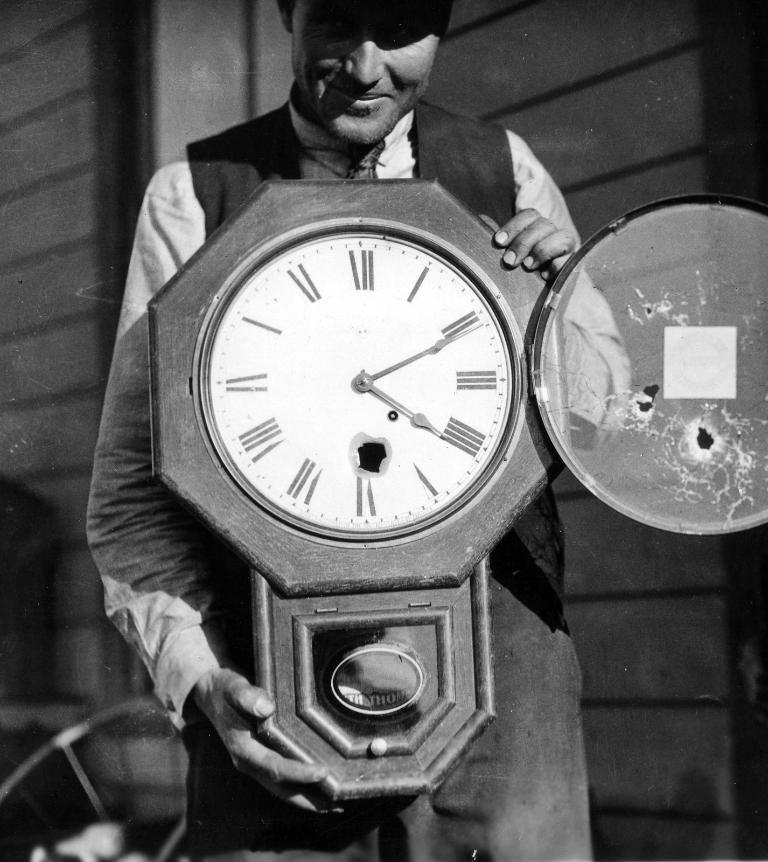What is the main subject of the image? There is a person standing in the middle of the image. What is the person holding in the image? The person is holding a clock. What can be seen behind the person in the image? There is a wall and a chair behind the person. How many bricks are visible on the wall behind the person? There is no information about bricks in the image, as it only mentions a wall behind the person. 